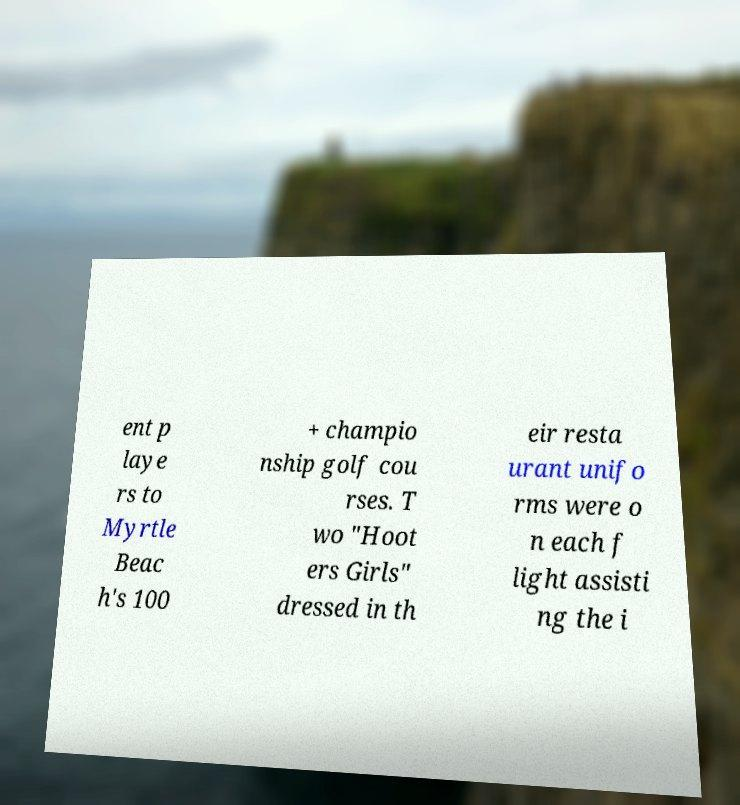Could you assist in decoding the text presented in this image and type it out clearly? ent p laye rs to Myrtle Beac h's 100 + champio nship golf cou rses. T wo "Hoot ers Girls" dressed in th eir resta urant unifo rms were o n each f light assisti ng the i 